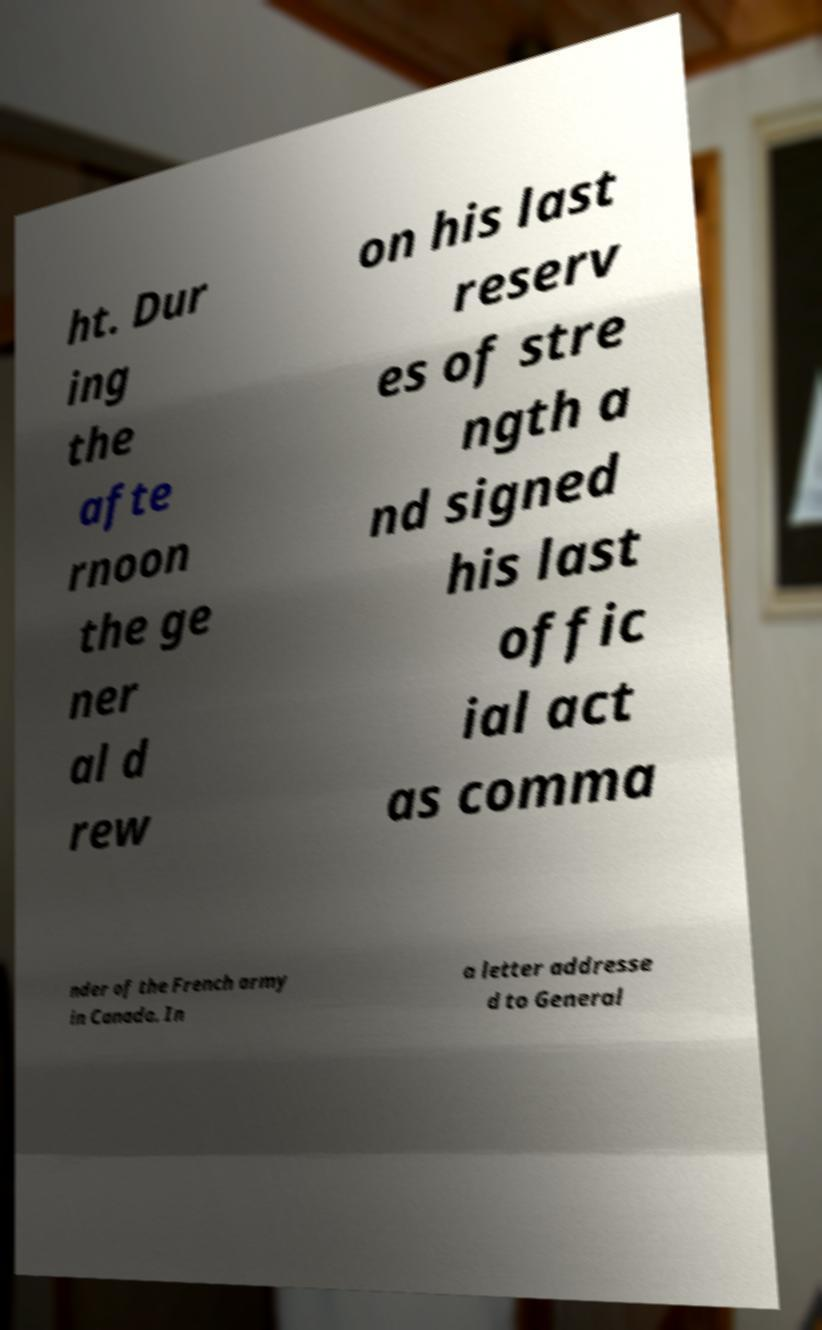Please read and relay the text visible in this image. What does it say? ht. Dur ing the afte rnoon the ge ner al d rew on his last reserv es of stre ngth a nd signed his last offic ial act as comma nder of the French army in Canada. In a letter addresse d to General 